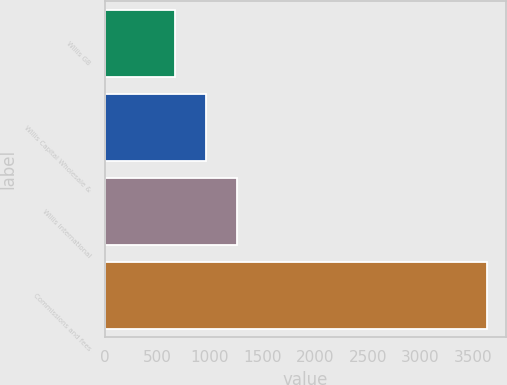<chart> <loc_0><loc_0><loc_500><loc_500><bar_chart><fcel>Willis GB<fcel>Willis Capital Wholesale &<fcel>Willis International<fcel>Commissions and fees<nl><fcel>665<fcel>961.8<fcel>1258.6<fcel>3633<nl></chart> 